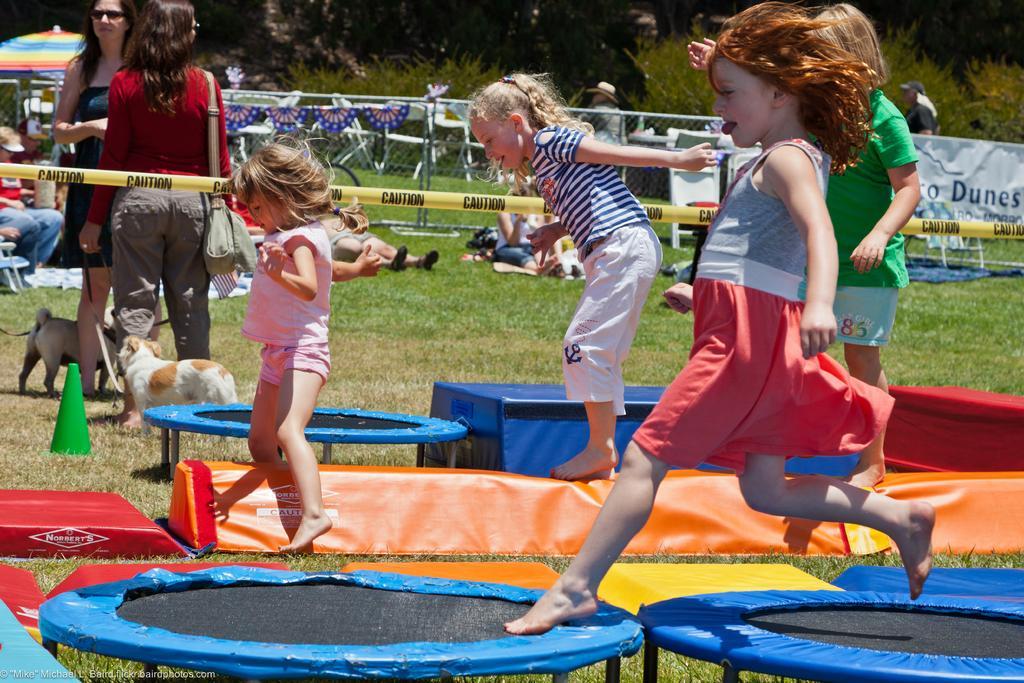Could you give a brief overview of what you see in this image? There is a group of people. The childrens are playing. On the left side of the persons are standing. They are wearing a spectacle. One woman is wearing a bag. We can see in the background fence,trees,banner. 